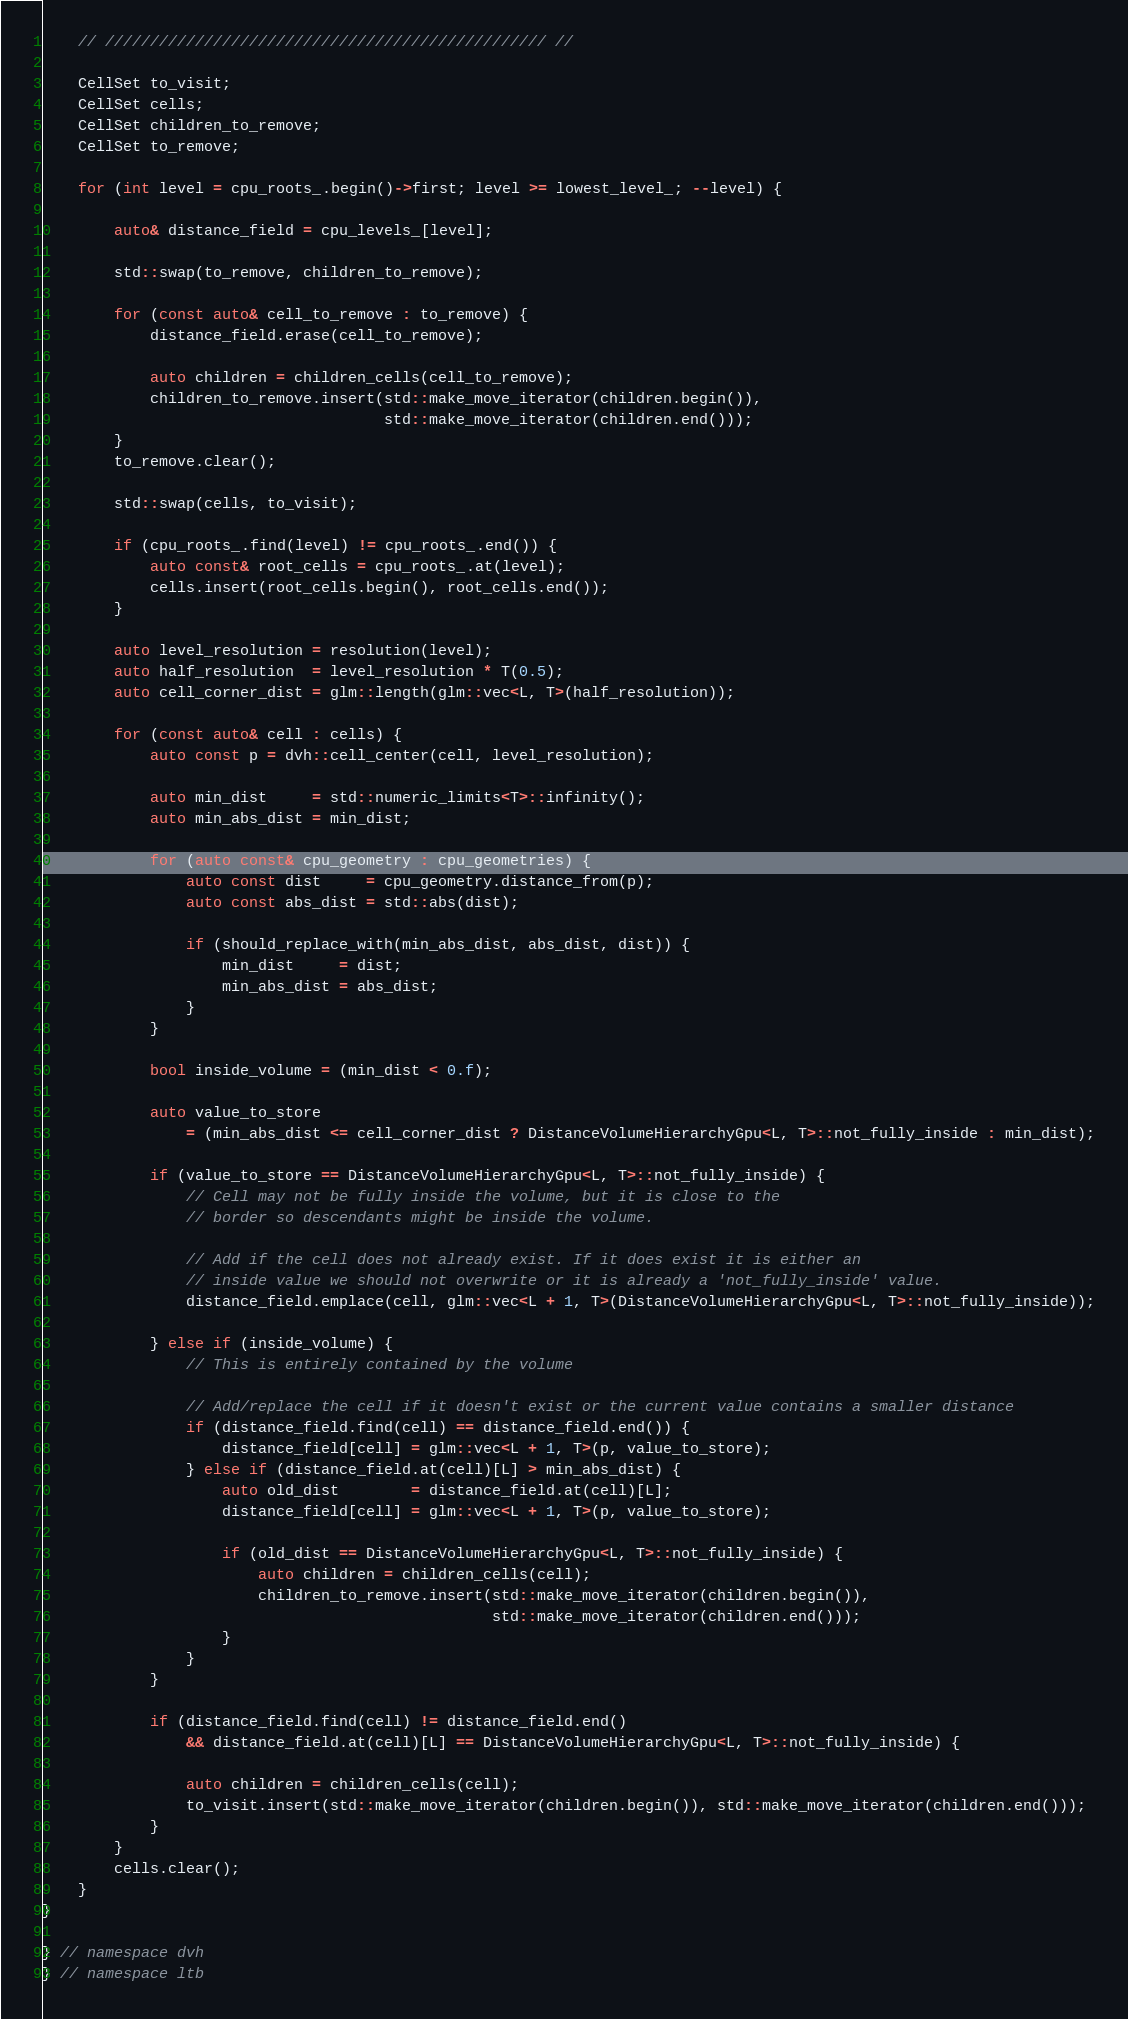<code> <loc_0><loc_0><loc_500><loc_500><_Cuda_>    // ///////////////////////////////////////////////// //

    CellSet to_visit;
    CellSet cells;
    CellSet children_to_remove;
    CellSet to_remove;

    for (int level = cpu_roots_.begin()->first; level >= lowest_level_; --level) {

        auto& distance_field = cpu_levels_[level];

        std::swap(to_remove, children_to_remove);

        for (const auto& cell_to_remove : to_remove) {
            distance_field.erase(cell_to_remove);

            auto children = children_cells(cell_to_remove);
            children_to_remove.insert(std::make_move_iterator(children.begin()),
                                      std::make_move_iterator(children.end()));
        }
        to_remove.clear();

        std::swap(cells, to_visit);

        if (cpu_roots_.find(level) != cpu_roots_.end()) {
            auto const& root_cells = cpu_roots_.at(level);
            cells.insert(root_cells.begin(), root_cells.end());
        }

        auto level_resolution = resolution(level);
        auto half_resolution  = level_resolution * T(0.5);
        auto cell_corner_dist = glm::length(glm::vec<L, T>(half_resolution));

        for (const auto& cell : cells) {
            auto const p = dvh::cell_center(cell, level_resolution);

            auto min_dist     = std::numeric_limits<T>::infinity();
            auto min_abs_dist = min_dist;

            for (auto const& cpu_geometry : cpu_geometries) {
                auto const dist     = cpu_geometry.distance_from(p);
                auto const abs_dist = std::abs(dist);

                if (should_replace_with(min_abs_dist, abs_dist, dist)) {
                    min_dist     = dist;
                    min_abs_dist = abs_dist;
                }
            }

            bool inside_volume = (min_dist < 0.f);

            auto value_to_store
                = (min_abs_dist <= cell_corner_dist ? DistanceVolumeHierarchyGpu<L, T>::not_fully_inside : min_dist);

            if (value_to_store == DistanceVolumeHierarchyGpu<L, T>::not_fully_inside) {
                // Cell may not be fully inside the volume, but it is close to the
                // border so descendants might be inside the volume.

                // Add if the cell does not already exist. If it does exist it is either an
                // inside value we should not overwrite or it is already a 'not_fully_inside' value.
                distance_field.emplace(cell, glm::vec<L + 1, T>(DistanceVolumeHierarchyGpu<L, T>::not_fully_inside));

            } else if (inside_volume) {
                // This is entirely contained by the volume

                // Add/replace the cell if it doesn't exist or the current value contains a smaller distance
                if (distance_field.find(cell) == distance_field.end()) {
                    distance_field[cell] = glm::vec<L + 1, T>(p, value_to_store);
                } else if (distance_field.at(cell)[L] > min_abs_dist) {
                    auto old_dist        = distance_field.at(cell)[L];
                    distance_field[cell] = glm::vec<L + 1, T>(p, value_to_store);

                    if (old_dist == DistanceVolumeHierarchyGpu<L, T>::not_fully_inside) {
                        auto children = children_cells(cell);
                        children_to_remove.insert(std::make_move_iterator(children.begin()),
                                                  std::make_move_iterator(children.end()));
                    }
                }
            }

            if (distance_field.find(cell) != distance_field.end()
                && distance_field.at(cell)[L] == DistanceVolumeHierarchyGpu<L, T>::not_fully_inside) {

                auto children = children_cells(cell);
                to_visit.insert(std::make_move_iterator(children.begin()), std::make_move_iterator(children.end()));
            }
        }
        cells.clear();
    }
}

} // namespace dvh
} // namespace ltb
</code> 